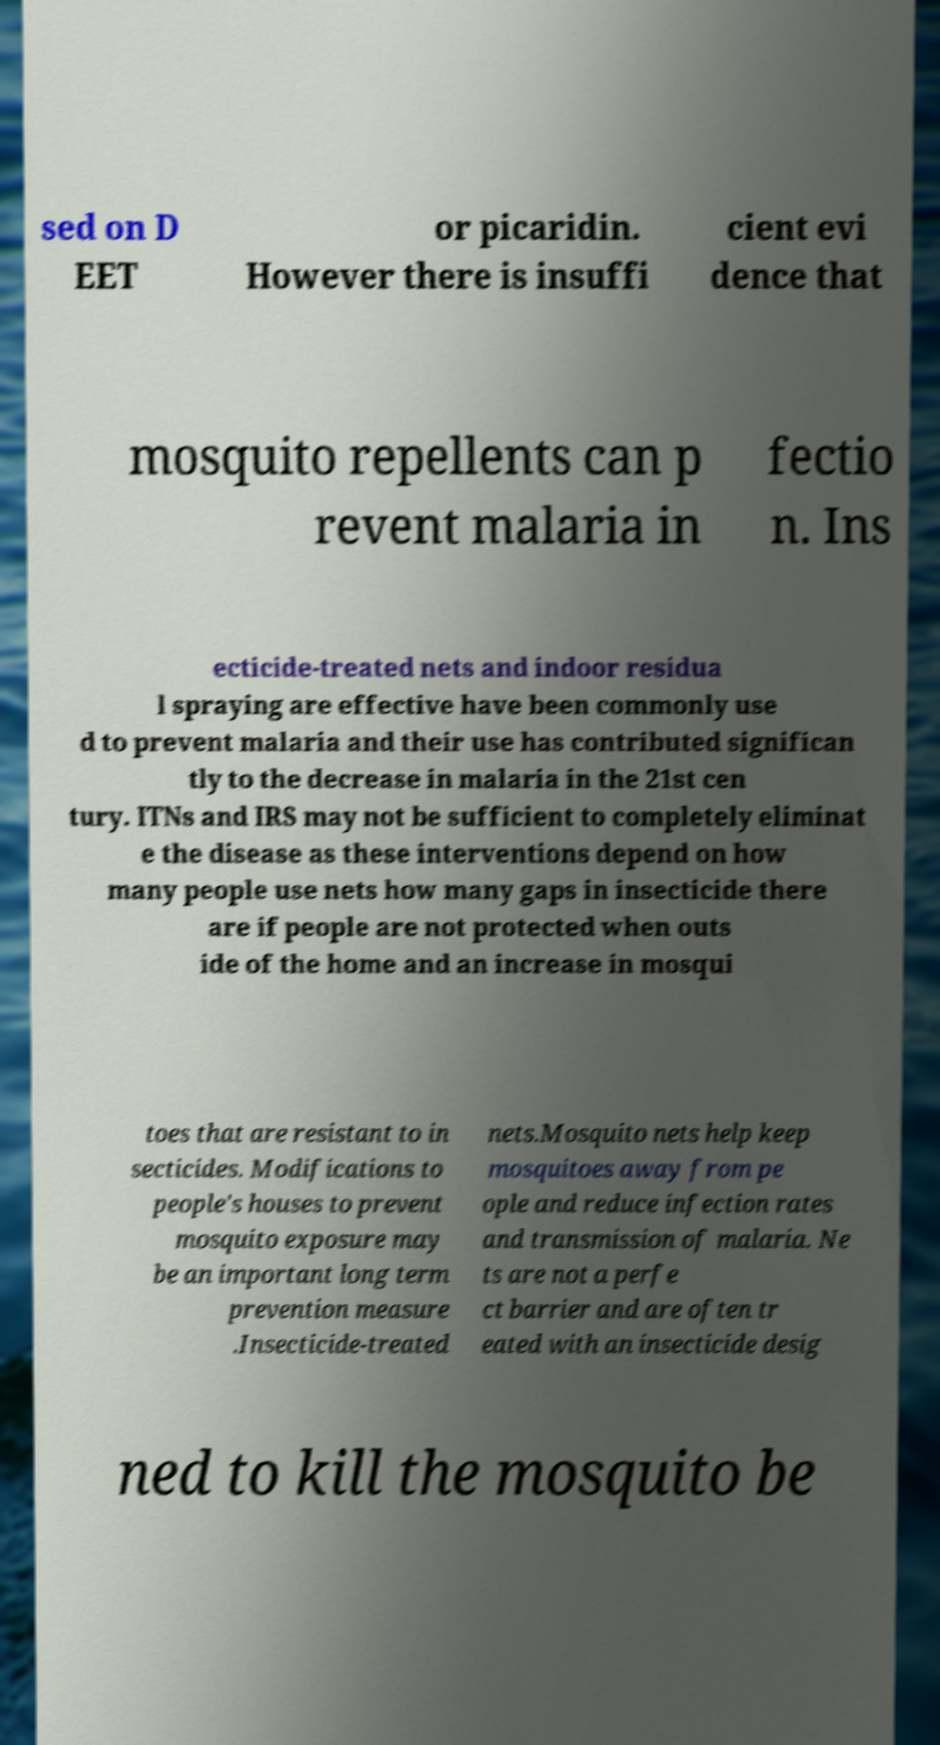For documentation purposes, I need the text within this image transcribed. Could you provide that? sed on D EET or picaridin. However there is insuffi cient evi dence that mosquito repellents can p revent malaria in fectio n. Ins ecticide-treated nets and indoor residua l spraying are effective have been commonly use d to prevent malaria and their use has contributed significan tly to the decrease in malaria in the 21st cen tury. ITNs and IRS may not be sufficient to completely eliminat e the disease as these interventions depend on how many people use nets how many gaps in insecticide there are if people are not protected when outs ide of the home and an increase in mosqui toes that are resistant to in secticides. Modifications to people's houses to prevent mosquito exposure may be an important long term prevention measure .Insecticide-treated nets.Mosquito nets help keep mosquitoes away from pe ople and reduce infection rates and transmission of malaria. Ne ts are not a perfe ct barrier and are often tr eated with an insecticide desig ned to kill the mosquito be 